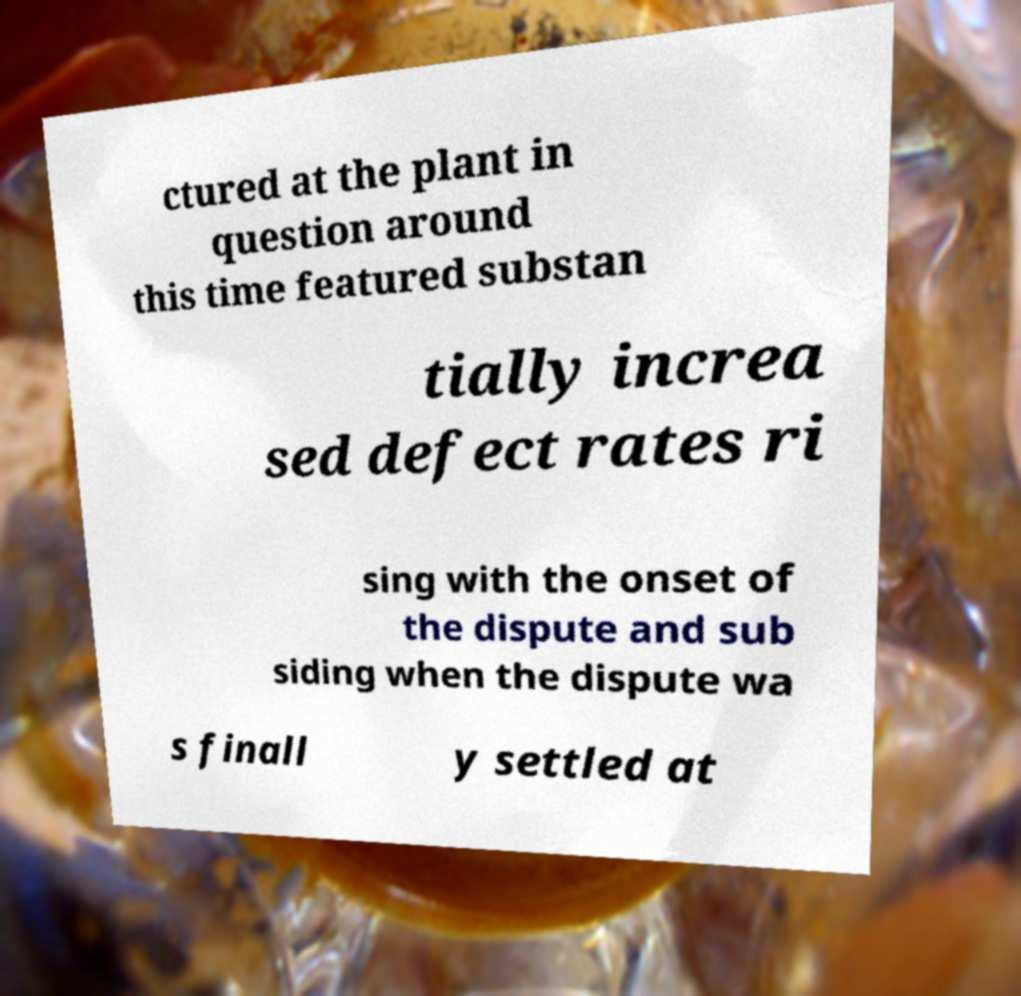There's text embedded in this image that I need extracted. Can you transcribe it verbatim? ctured at the plant in question around this time featured substan tially increa sed defect rates ri sing with the onset of the dispute and sub siding when the dispute wa s finall y settled at 